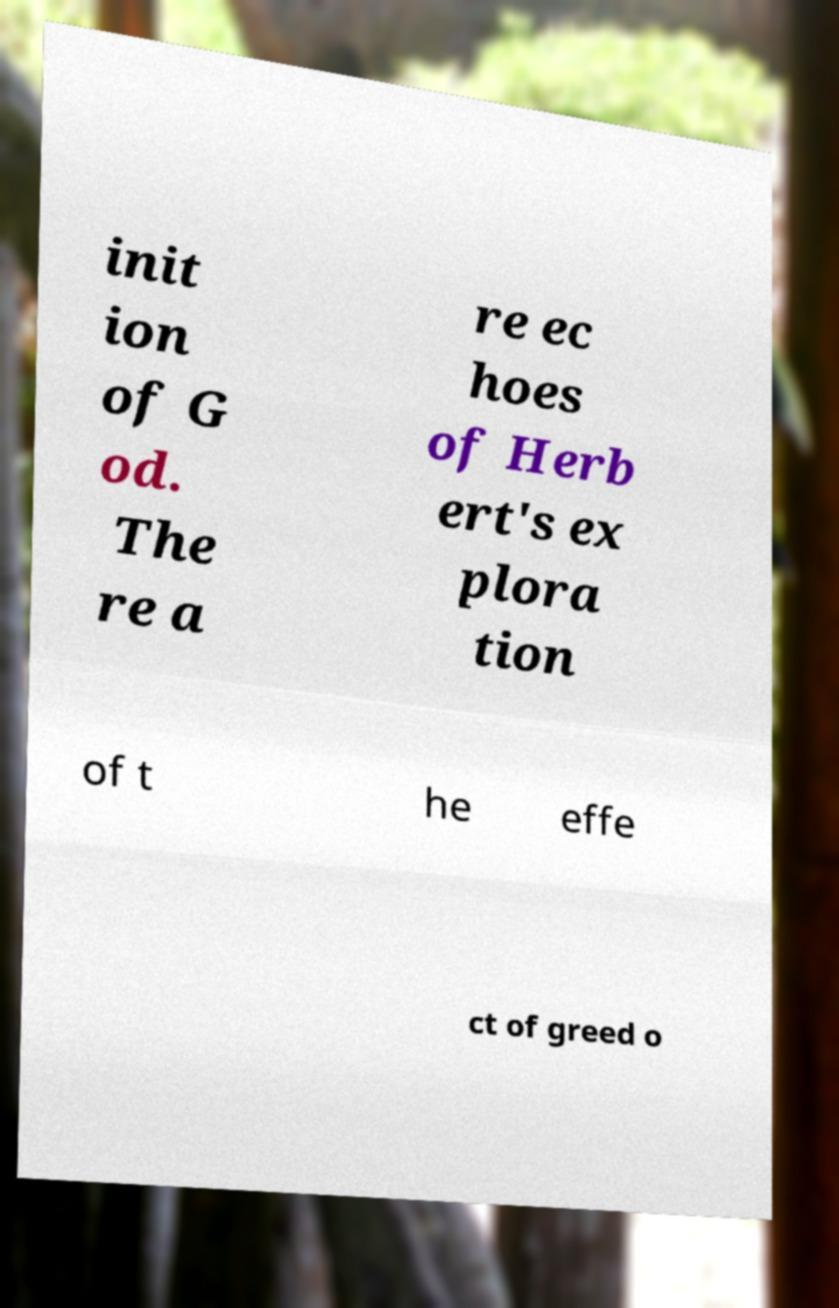Could you extract and type out the text from this image? init ion of G od. The re a re ec hoes of Herb ert's ex plora tion of t he effe ct of greed o 